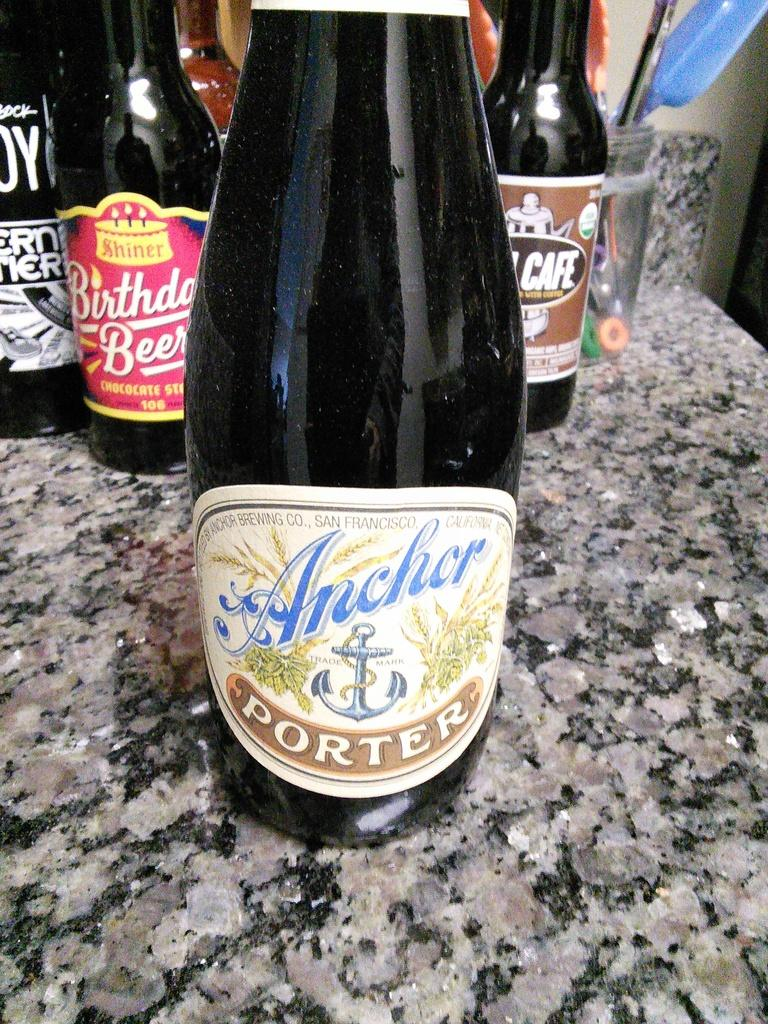<image>
Create a compact narrative representing the image presented. A bottle that is labelled Anchor Porter is resting on a counter. 